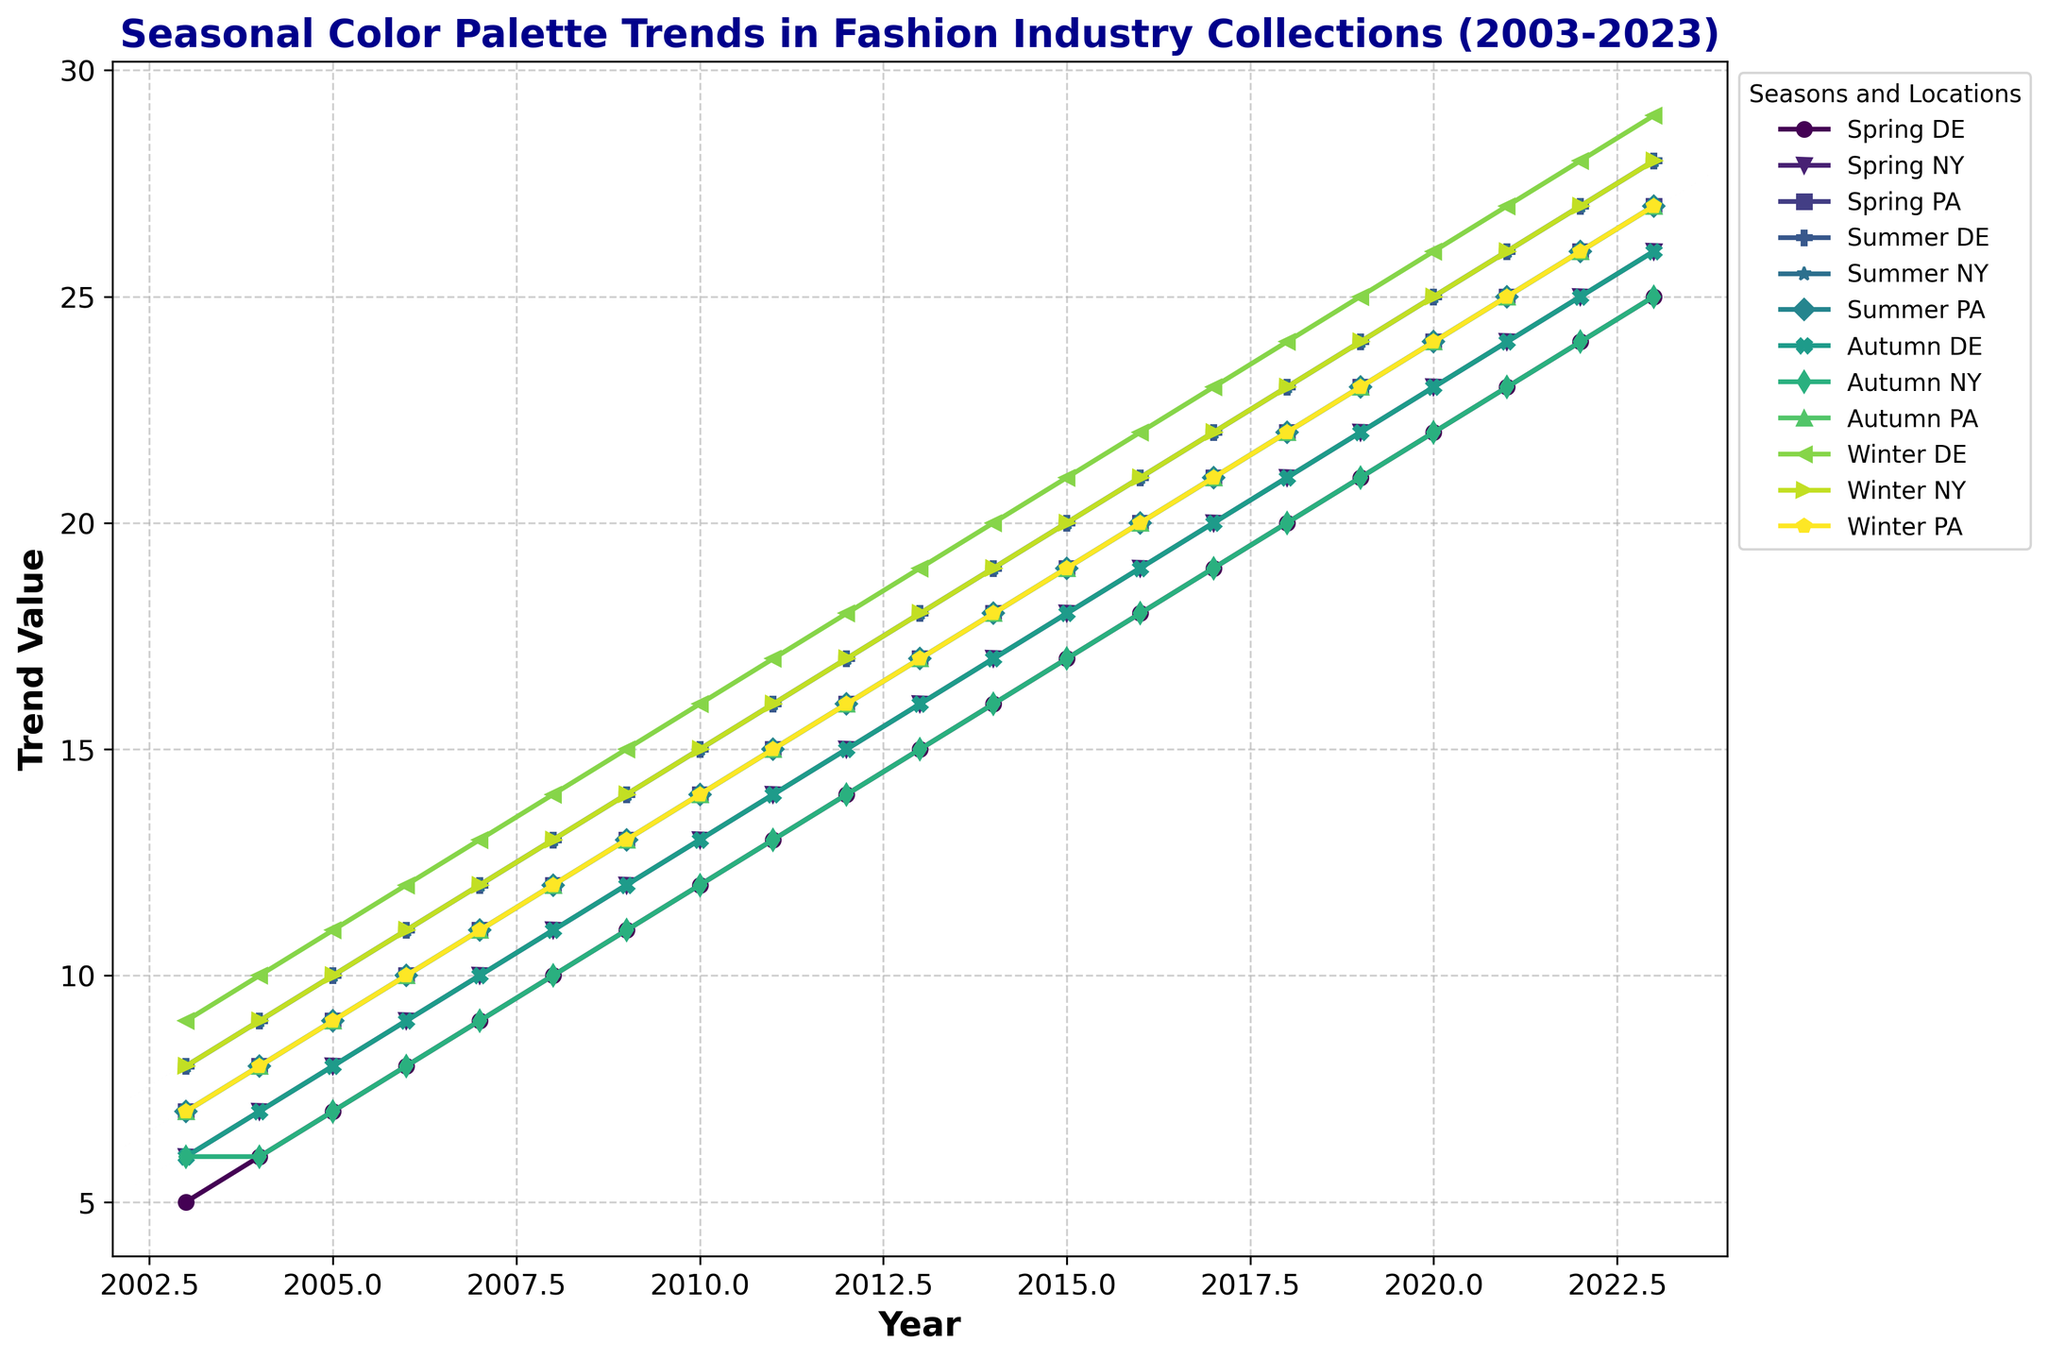What year shows the highest trend value for Spring in New York? Look at the plot for the 'Spring NY' line. Identify the highest point, which visually aligns with the year on the x-axis.
Answer: 2023 Which season and location had the lowest trend value in 2003? Locate the data points for the year 2003 on the x-axis. Compare all the trend values for different seasons and locations, identifying the lowest one.
Answer: Spring DE Between 2015 and 2020, which season's trend in Paris shows the most significant increase? Compare the trend lines for all seasons in Paris ('Spring PA', 'Summer PA', 'Autumn PA', 'Winter PA') between 2015 and 2020. Calculate the trend value increase for each season.
Answer: Winter PA In 2010, how does the trend value for Summer in New York compare to Autumn in Germany? Find the trend values for 'Summer NY' and 'Autumn DE' in 2010 on the y-axis. Compare the two values.
Answer: Summer NY is higher What is the average trend value for Winter in all locations in 2021? Retrieve the trend values for 'Winter DE', 'Winter NY', and 'Winter PA' in 2021 and compute their average.
Answer: 26 Which season in Paris had the most consistent increase in trend value from 2003 to 2023? Analyze the slope and linearity of the trend lines for Paris across all seasons. Determine which line shows the most consistent increase.
Answer: Winter PA How much higher is the trend value for Summer in New York in 2023 compared to 2003? Subtract the trend value for 'Summer NY' in 2003 from the value in 2023.
Answer: 20 What color represents the Spring trends? Identify the colors used for the lines labeled as 'Spring'. Check the legend to see the corresponding color.
Answer: Green (or another specified color from the legend, if different) Which trend line has the steepest incline between 2003 and 2007? Analyze the slopes of all the trend lines in the given period and determine the one with the sharpest upward trend.
Answer: Winter DE By how much does the trend value for Autumn in Germany in 2023 exceed that in 2018? Subtract the trend value for 'Autumn DE' in 2018 from the value in 2023.
Answer: 5 